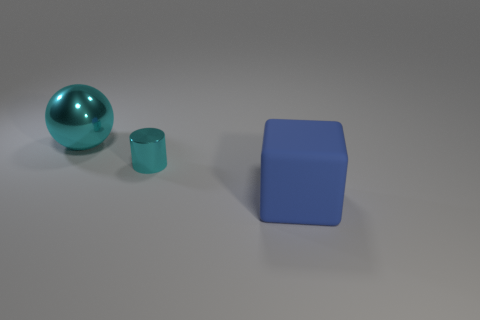Add 1 small brown matte blocks. How many objects exist? 4 Subtract all blocks. How many objects are left? 2 Add 2 small cylinders. How many small cylinders exist? 3 Subtract 1 cyan spheres. How many objects are left? 2 Subtract all small yellow matte cubes. Subtract all matte cubes. How many objects are left? 2 Add 1 large things. How many large things are left? 3 